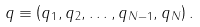Convert formula to latex. <formula><loc_0><loc_0><loc_500><loc_500>q \equiv \left ( q _ { 1 } , q _ { 2 } , \dots , q _ { N - 1 } , q _ { N } \right ) .</formula> 